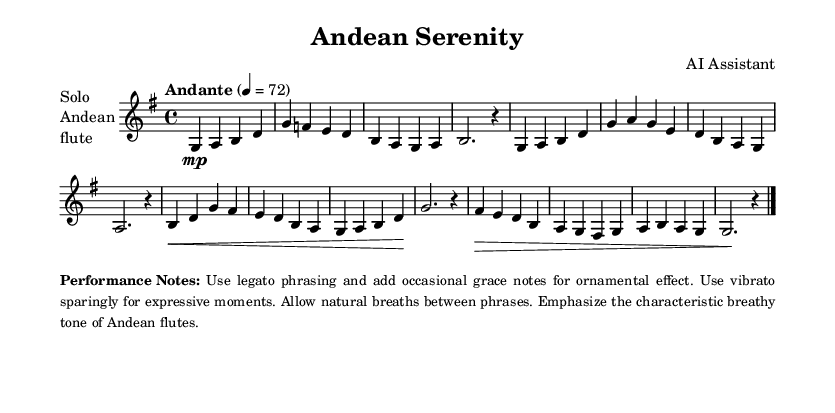What is the key signature of this music? The key signature is G major, indicated by the presence of one sharp (F#) in the sheet music. This can be identified on the left side of the staff where the key signature is notated.
Answer: G major What is the time signature of this music? The time signature shown in the sheet music is 4/4, which means there are four beats per measure and a quarter note receives one beat. This is indicated at the beginning of the score right after the key signature.
Answer: 4/4 What is the tempo marking of this piece? The tempo marking indicates "Andante," which signifies a moderately slow tempo. It's found at the beginning of the score, specifying the speed of the piece.
Answer: Andante How many measures are in this score? There are ten measures in total, counted from the beginning to the end of the piece. Each measure is separated by vertical lines, which are the bar lines.
Answer: 10 What technique is recommended to emphasize the Andean flute's tone? The performance notes recommend emphasizing the "breathy tone" characteristic of Andean flutes, which can be achieved through specific playing techniques noted in the performance instructions.
Answer: Breathy tone Which dynamic marking appears in this music? The dynamic marking shown in the music is "mp," which indicates a moderately soft dynamic level. This marking is seen at the beginning of the first measure.
Answer: mp What is the significance of the grace notes in this piece? Grace notes are suggested for ornamental effect, adding expressiveness to the melody. They should be used sparingly as indicated in the performance notes, contributing to the overall style of the music.
Answer: Ornamental effect 